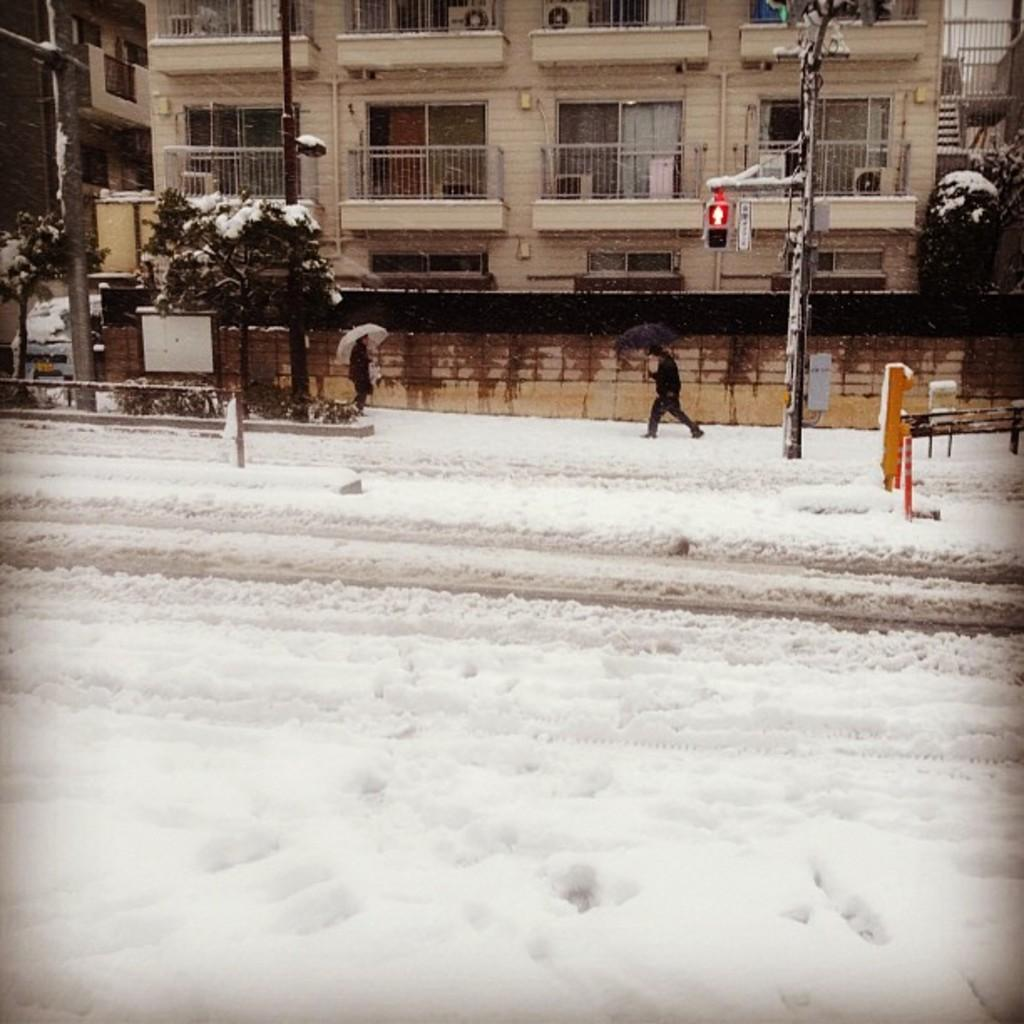What type of structures can be seen in the image? There are buildings in the image. What other natural elements are present in the image? There are trees in the image. What are the tall, thin objects in the image? There are poles in the image. What are the people in the image using to protect themselves from the weather? People are holding umbrellas in the image. What is the ground condition in the image? People are walking on the snow in the image. Can you see any fairies flying around the buildings in the image? There are no fairies present in the image; it features buildings, trees, poles, people with umbrellas, and snow. What type of vest is the prison guard wearing in the image? There is no prison or prison guard present in the image. 